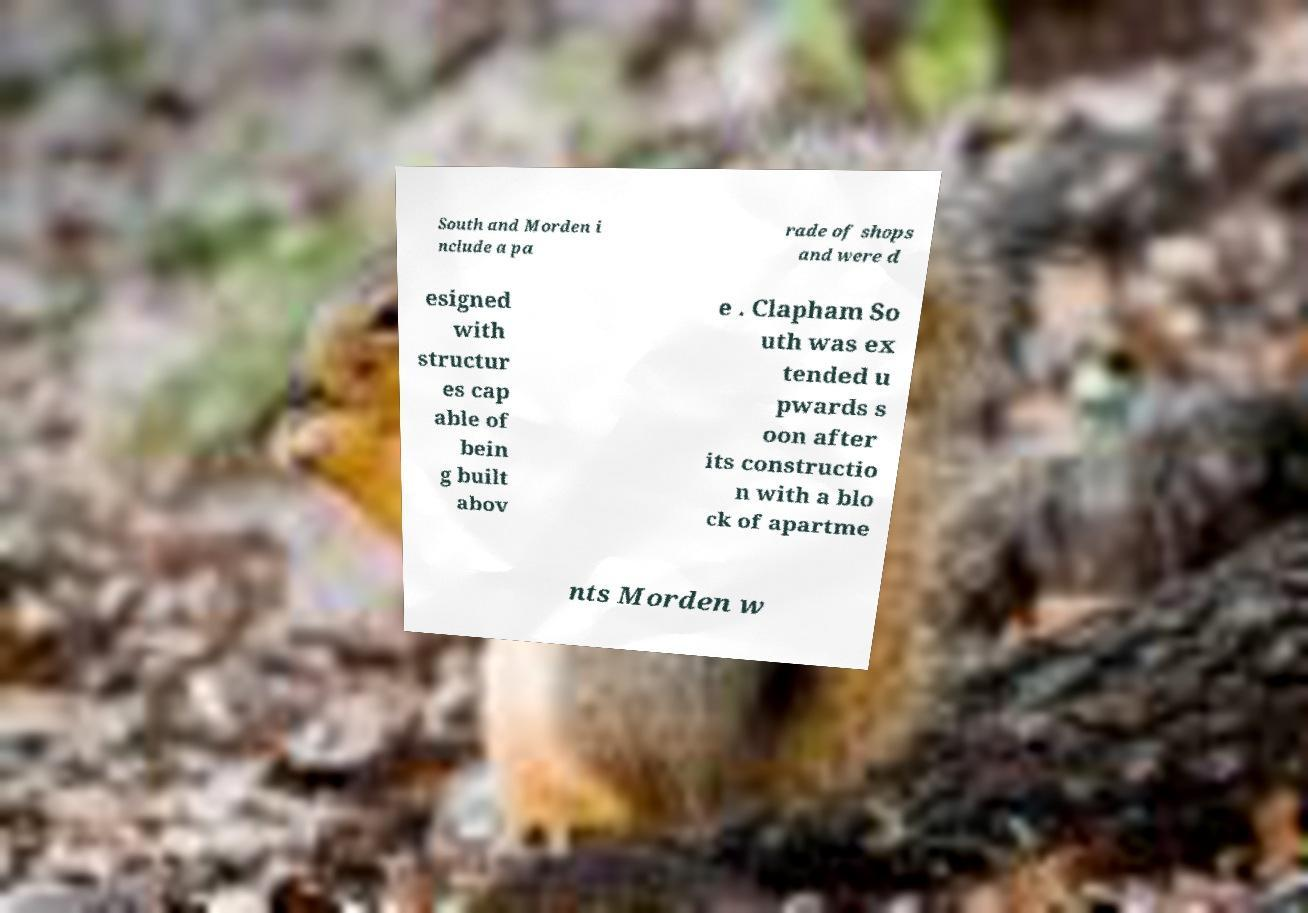Could you extract and type out the text from this image? South and Morden i nclude a pa rade of shops and were d esigned with structur es cap able of bein g built abov e . Clapham So uth was ex tended u pwards s oon after its constructio n with a blo ck of apartme nts Morden w 